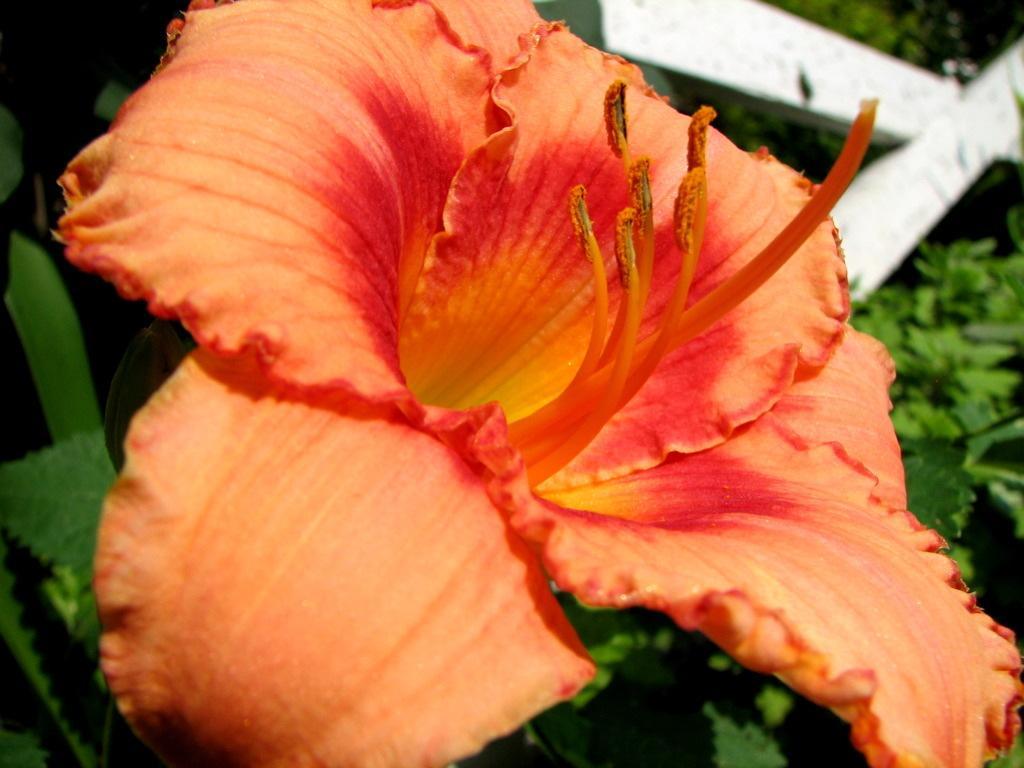How would you summarize this image in a sentence or two? In the picture I can see an orange color flower of a plant and the background of the image is blurred, where we can see a few more plants and a white color object. 